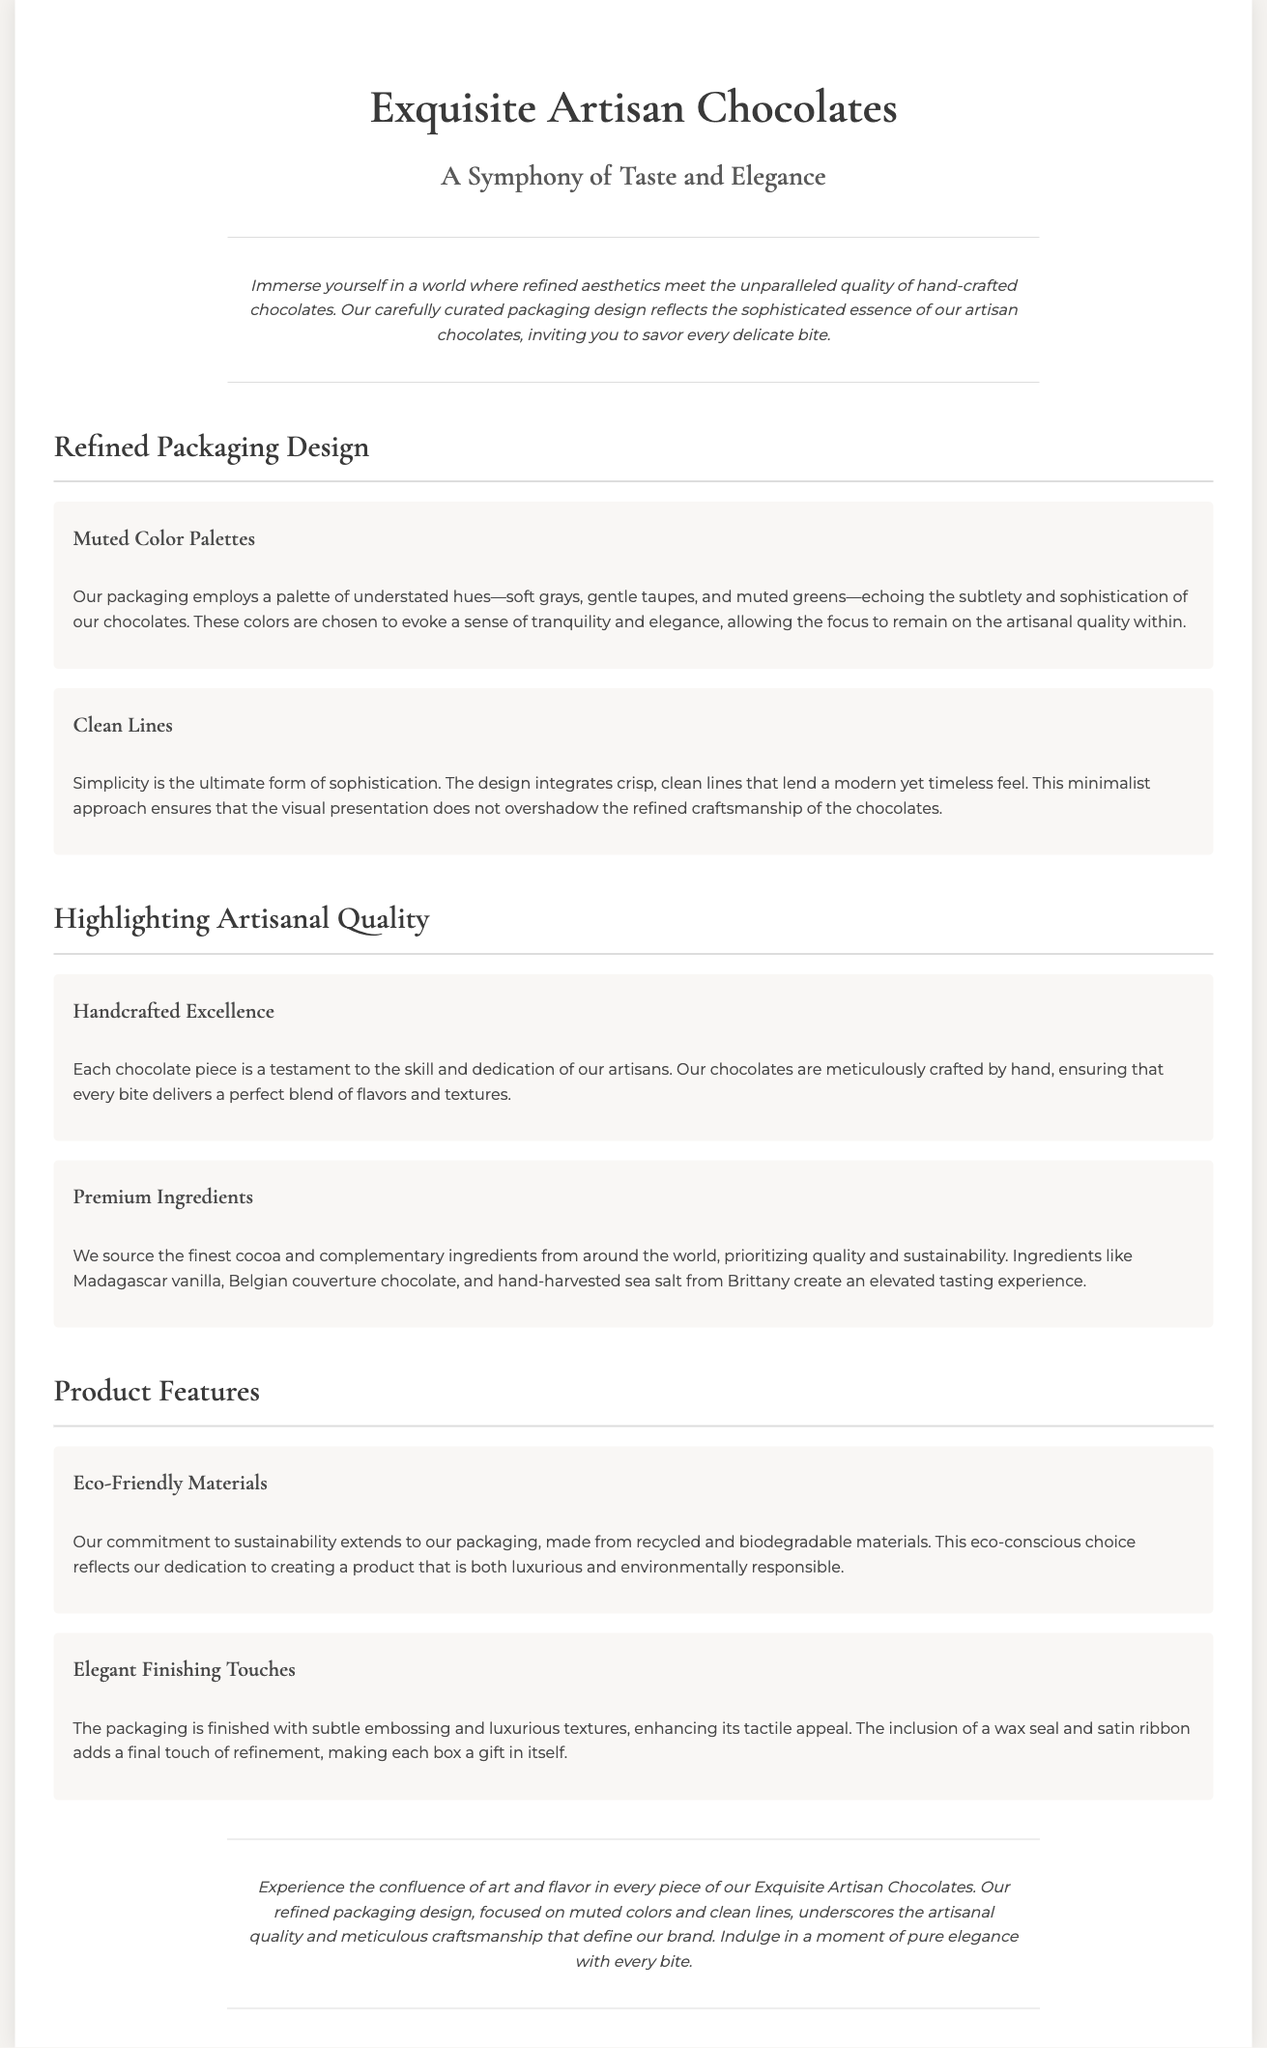What is the name of the product? The name of the product is explicitly mentioned in the header of the document.
Answer: Exquisite Artisan Chocolates What color palettes are used in the packaging? The document specifies the color palettes used in the packaging in one of the sections.
Answer: Muted color palettes What is emphasized in the packaging design? The design's focus is stated in the document to convey its characteristics clearly.
Answer: Clean lines What type of ingredients are prioritized? The document highlights specific ingredient qualities in one of the sections.
Answer: Premium ingredients How is the packaging described in terms of sustainability? The sustainability approach is detailed in a specific section about product features.
Answer: Eco-Friendly Materials What kind of finish is mentioned for the packaging? The document outlines the finishing touches given to enhance the packaging's quality.
Answer: Elegant Finishing Touches What is a key characteristic of the chocolates? The document mentions the skill involved in the chocolate-making process.
Answer: Handcrafted Excellence How does the packaging evoke emotions? This is inferred from the description of the color palette and overall design.
Answer: Tranquility and elegance What creates an elevated tasting experience? The document describes elements contributing to an extraordinary flavor experience.
Answer: Madagascar vanilla, Belgian couverture chocolate, and hand-harvested sea salt from Brittany 